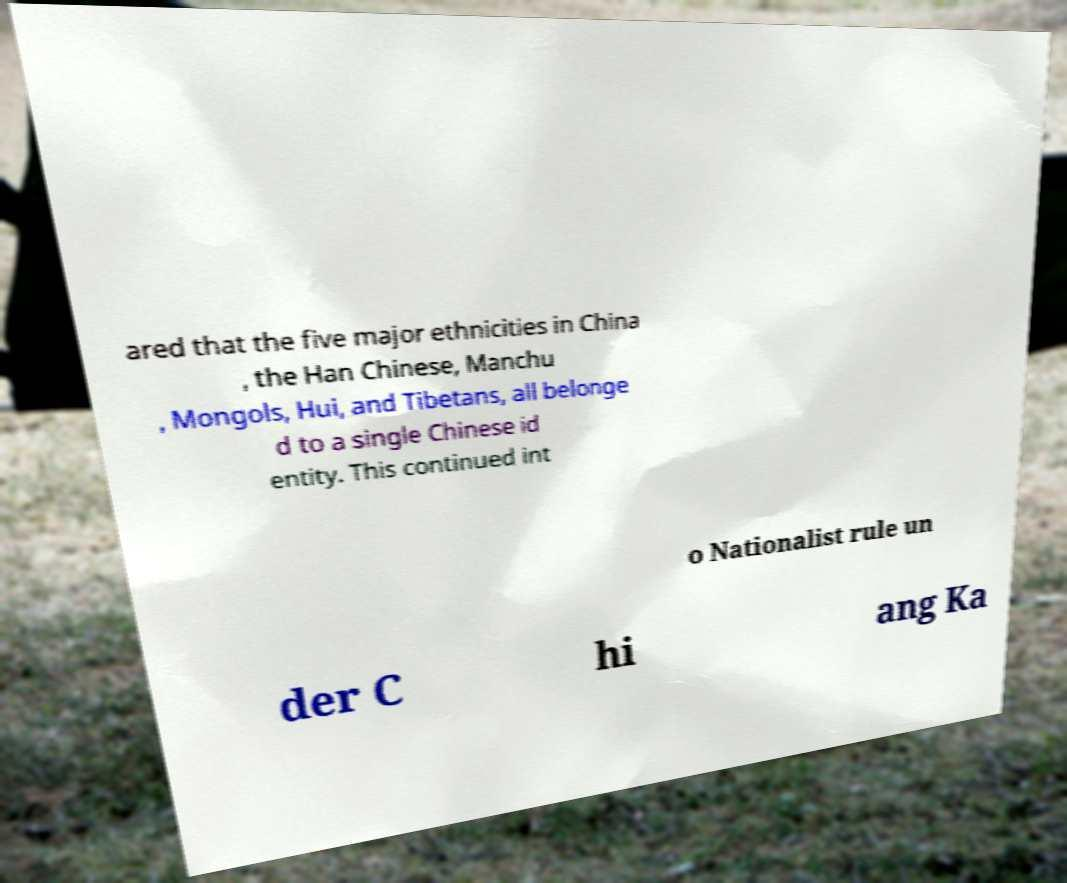Could you extract and type out the text from this image? ared that the five major ethnicities in China , the Han Chinese, Manchu , Mongols, Hui, and Tibetans, all belonge d to a single Chinese id entity. This continued int o Nationalist rule un der C hi ang Ka 